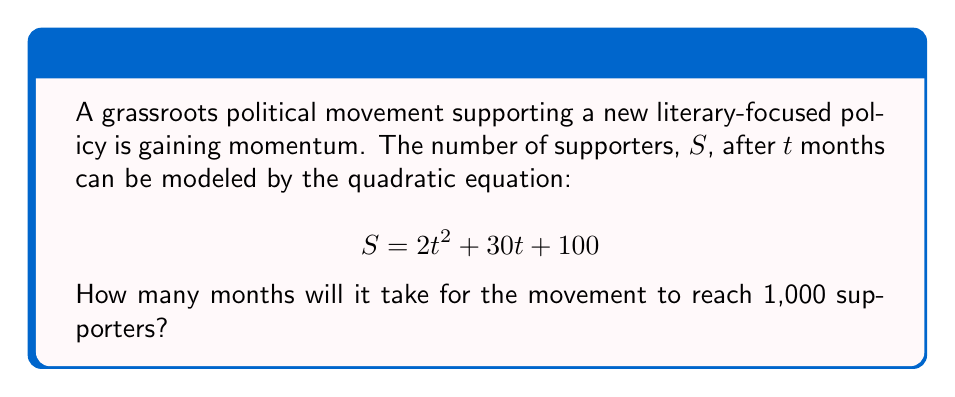Help me with this question. To solve this problem, we need to follow these steps:

1) We want to find $t$ when $S = 1000$. So, we set up the equation:

   $$1000 = 2t^2 + 30t + 100$$

2) Rearrange the equation to standard form:

   $$2t^2 + 30t - 900 = 0$$

3) This is a quadratic equation in the form $at^2 + bt + c = 0$, where:
   $a = 2$, $b = 30$, and $c = -900$

4) We can solve this using the quadratic formula: $t = \frac{-b \pm \sqrt{b^2 - 4ac}}{2a}$

5) Substituting our values:

   $$t = \frac{-30 \pm \sqrt{30^2 - 4(2)(-900)}}{2(2)}$$

6) Simplify under the square root:

   $$t = \frac{-30 \pm \sqrt{900 + 7200}}{4} = \frac{-30 \pm \sqrt{8100}}{4}$$

7) Simplify further:

   $$t = \frac{-30 \pm 90}{4}$$

8) This gives us two solutions:

   $$t = \frac{-30 + 90}{4} = \frac{60}{4} = 15$$
   $$t = \frac{-30 - 90}{4} = \frac{-120}{4} = -30$$

9) Since time cannot be negative in this context, we discard the negative solution.

Therefore, it will take 15 months for the movement to reach 1,000 supporters.
Answer: 15 months 